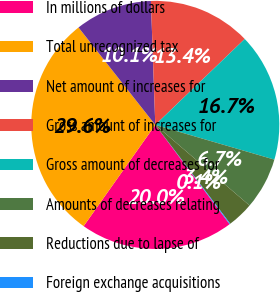Convert chart. <chart><loc_0><loc_0><loc_500><loc_500><pie_chart><fcel>In millions of dollars<fcel>Total unrecognized tax<fcel>Net amount of increases for<fcel>Gross amount of increases for<fcel>Gross amount of decreases for<fcel>Amounts of decreases relating<fcel>Reductions due to lapse of<fcel>Foreign exchange acquisitions<nl><fcel>20.03%<fcel>29.58%<fcel>10.06%<fcel>13.38%<fcel>16.7%<fcel>6.74%<fcel>3.42%<fcel>0.1%<nl></chart> 